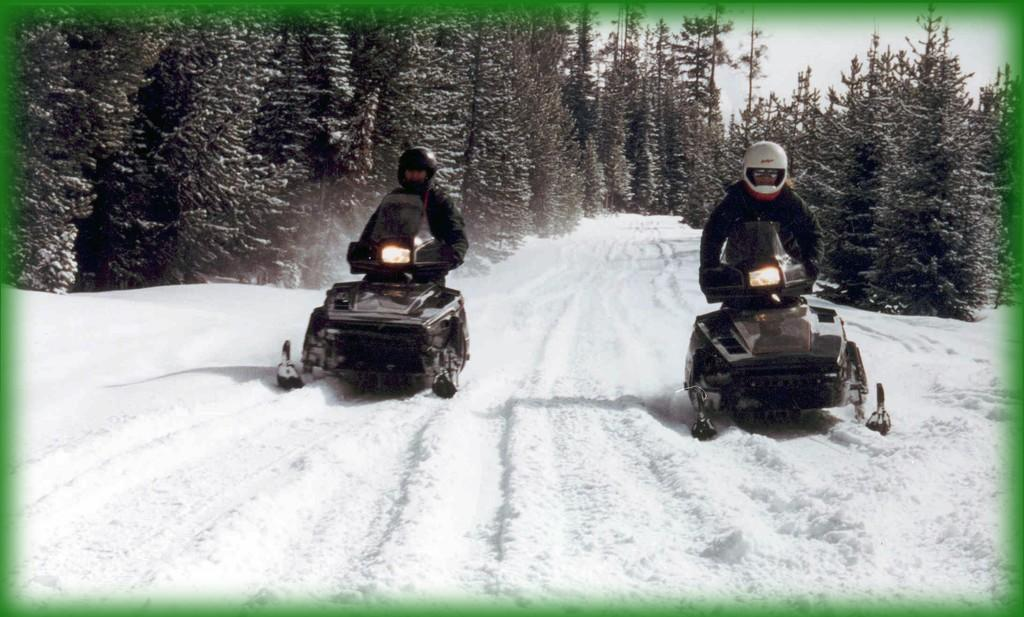What is happening in the image? There are people driving vehicles in the image. What type of terrain can be seen in the image? The vehicles are on a snow floor. What can be seen in the background of the image? There are trees in the background of the image. How many cakes are being transported by the vehicles in the image? There are no cakes visible in the image; the vehicles are not carrying any cakes. What type of cart is being used to pull the coil in the image? There is no cart or coil present in the image. 